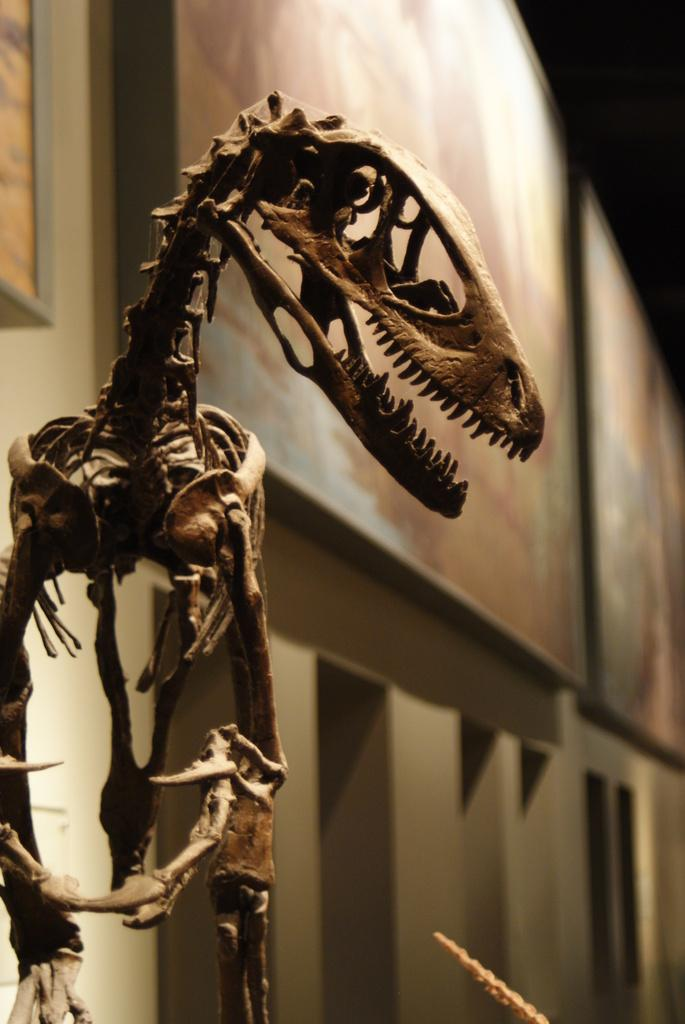What is the main subject of the image? There is a skeleton in the image. What else can be seen in the image besides the skeleton? There are boards and a wall in the image. What type of pen is the skeleton using to sign the documents at the meeting? There is no pen or meeting present in the image; it only features a skeleton, boards, and a wall. 